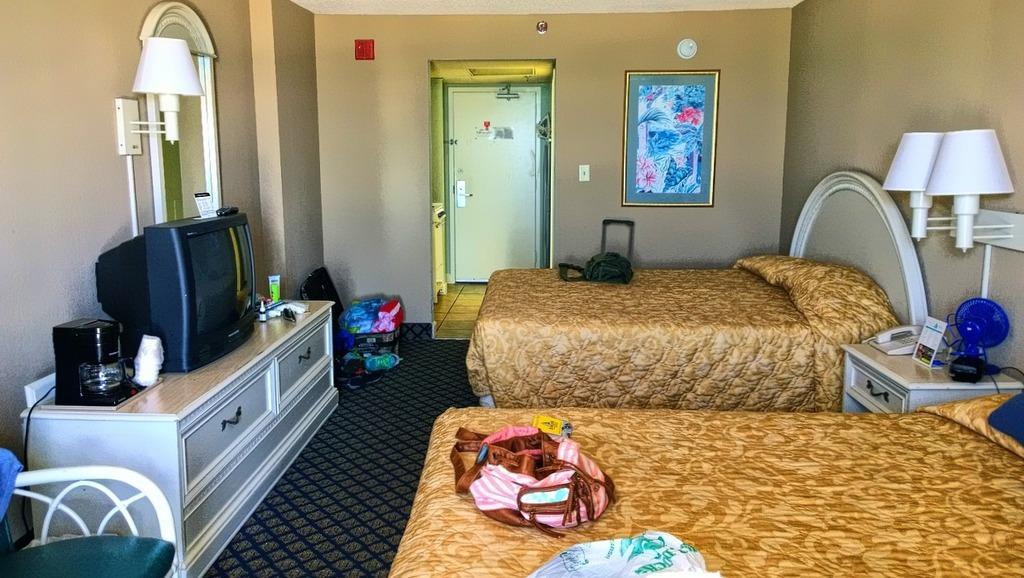Can you describe this image briefly? This is the inside view of a room, In this image there are beds with pillows and there are some objects on the beds, in between the beds there is a table with some objects, beside the bed there are lamps on the wall and there is a photo frame and there is an entrance connecting to another room, in front of the beds on the table there is a television and some other objects, a mirror and a lamp on the wall and an empty chair and there are some objects on the floor. 